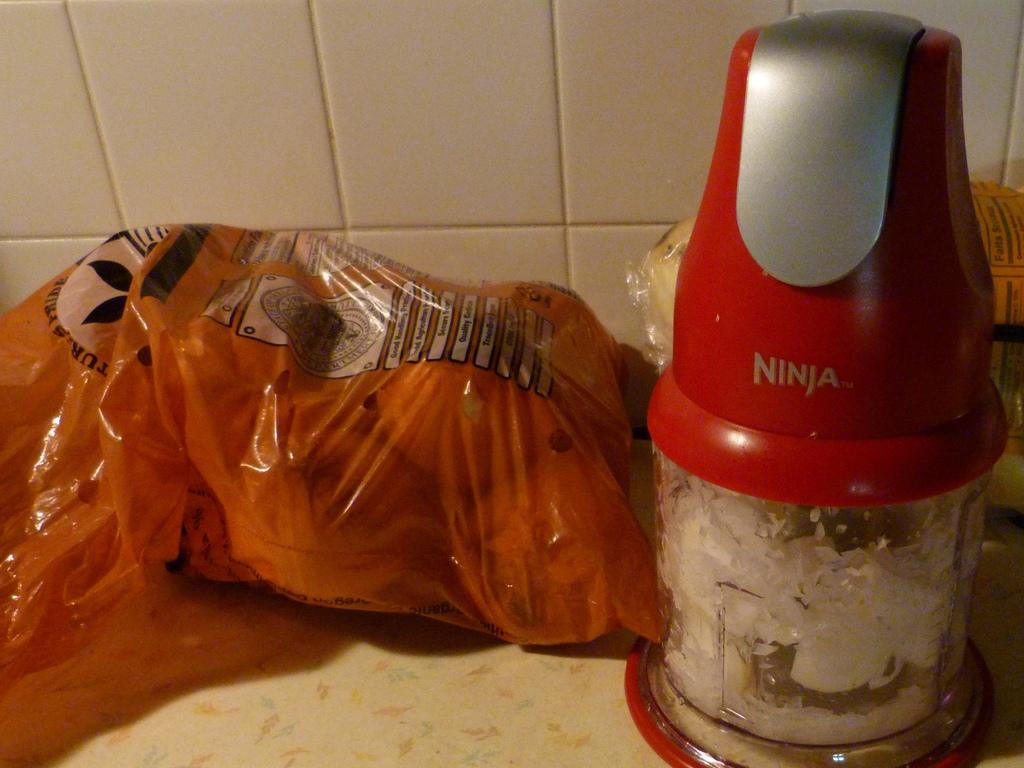What is the main object in the image? There is a grinder in the image. What is inside the grinder? There is a packet of items in the grinder. Can you describe any other objects in the image? There is an unspecified object in the image. What can be seen in the background of the image? The background of the image includes tiles. What type of flower is growing on the tiles in the image? There are no flowers present in the image; the background consists of tiles. 